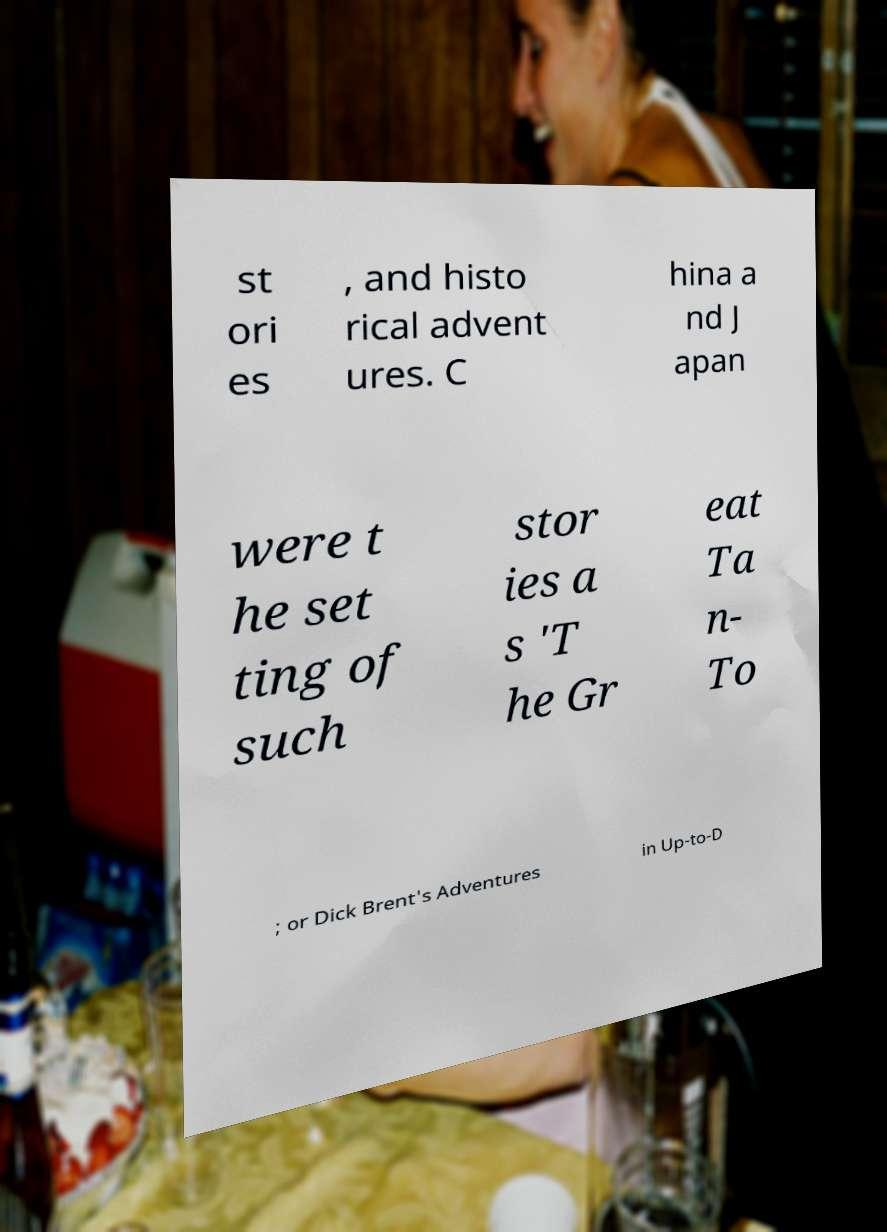For documentation purposes, I need the text within this image transcribed. Could you provide that? st ori es , and histo rical advent ures. C hina a nd J apan were t he set ting of such stor ies a s 'T he Gr eat Ta n- To ; or Dick Brent's Adventures in Up-to-D 